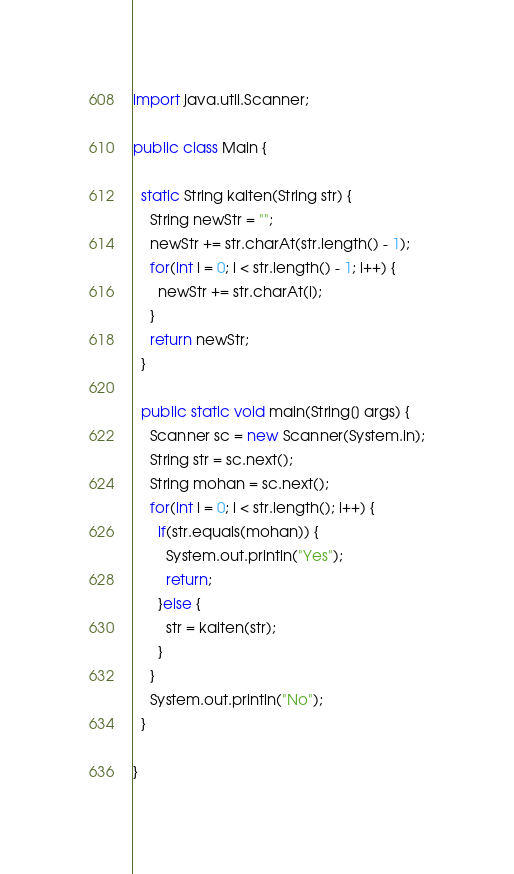<code> <loc_0><loc_0><loc_500><loc_500><_Java_>import java.util.Scanner;

public class Main {
  
  static String kaiten(String str) {
    String newStr = "";
    newStr += str.charAt(str.length() - 1);
    for(int i = 0; i < str.length() - 1; i++) {
      newStr += str.charAt(i);
    }
    return newStr;
  }

  public static void main(String[] args) {
    Scanner sc = new Scanner(System.in);
    String str = sc.next();
    String mohan = sc.next();
    for(int i = 0; i < str.length(); i++) {
      if(str.equals(mohan)) {
        System.out.println("Yes");
        return;
      }else {
        str = kaiten(str);
      }
    }
    System.out.println("No");
  }

}
</code> 